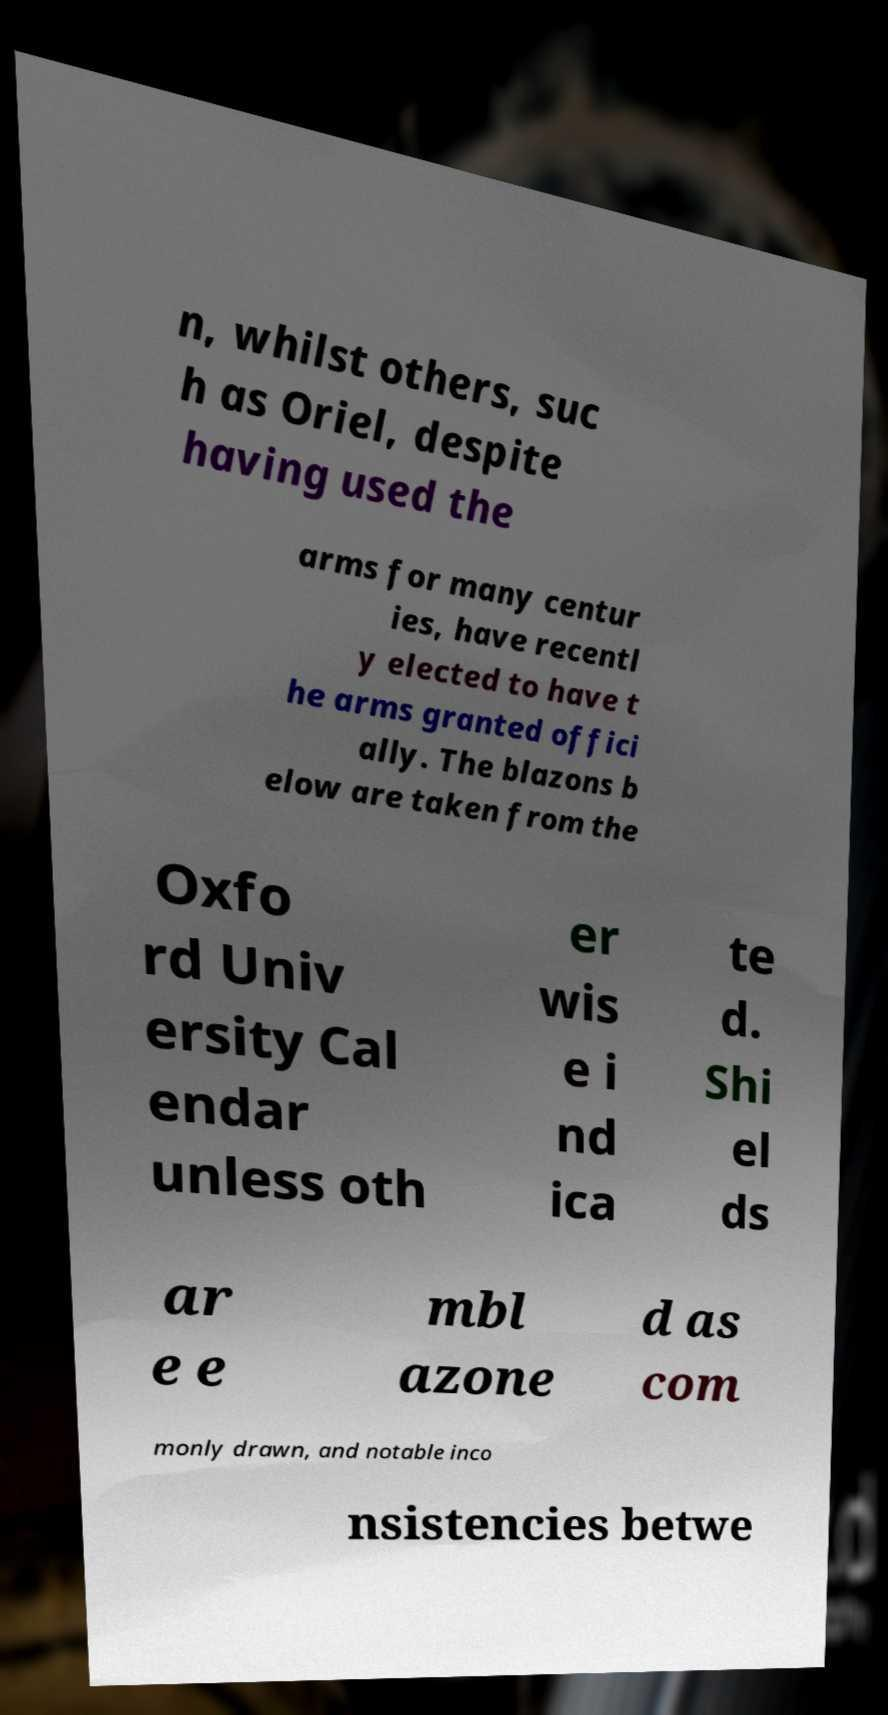Can you read and provide the text displayed in the image?This photo seems to have some interesting text. Can you extract and type it out for me? n, whilst others, suc h as Oriel, despite having used the arms for many centur ies, have recentl y elected to have t he arms granted offici ally. The blazons b elow are taken from the Oxfo rd Univ ersity Cal endar unless oth er wis e i nd ica te d. Shi el ds ar e e mbl azone d as com monly drawn, and notable inco nsistencies betwe 